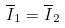<formula> <loc_0><loc_0><loc_500><loc_500>\overline { I } _ { 1 } = \overline { I } _ { 2 }</formula> 